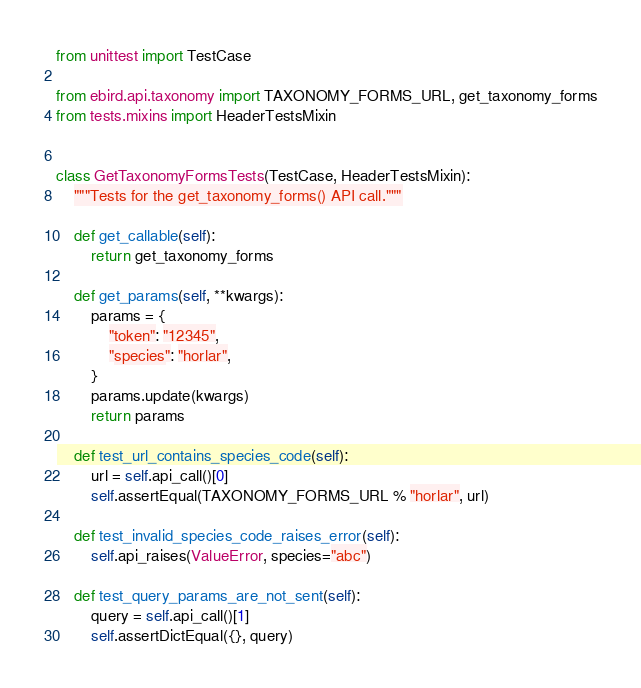<code> <loc_0><loc_0><loc_500><loc_500><_Python_>from unittest import TestCase

from ebird.api.taxonomy import TAXONOMY_FORMS_URL, get_taxonomy_forms
from tests.mixins import HeaderTestsMixin


class GetTaxonomyFormsTests(TestCase, HeaderTestsMixin):
    """Tests for the get_taxonomy_forms() API call."""

    def get_callable(self):
        return get_taxonomy_forms

    def get_params(self, **kwargs):
        params = {
            "token": "12345",
            "species": "horlar",
        }
        params.update(kwargs)
        return params

    def test_url_contains_species_code(self):
        url = self.api_call()[0]
        self.assertEqual(TAXONOMY_FORMS_URL % "horlar", url)

    def test_invalid_species_code_raises_error(self):
        self.api_raises(ValueError, species="abc")

    def test_query_params_are_not_sent(self):
        query = self.api_call()[1]
        self.assertDictEqual({}, query)
</code> 